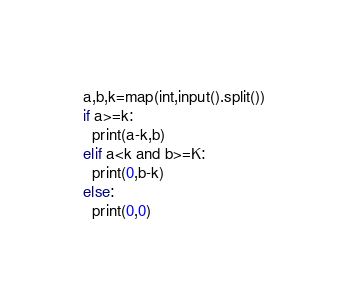<code> <loc_0><loc_0><loc_500><loc_500><_Python_>a,b,k=map(int,input().split())
if a>=k:
  print(a-k,b)
elif a<k and b>=K:
  print(0,b-k)
else:
  print(0,0)</code> 